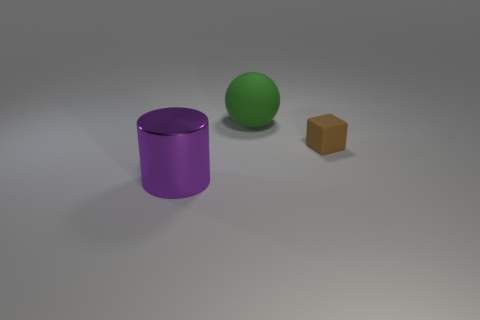Subtract all cubes. How many objects are left? 2 Add 1 large gray cylinders. How many large gray cylinders exist? 1 Add 2 big purple cylinders. How many objects exist? 5 Subtract 0 red blocks. How many objects are left? 3 Subtract all red cylinders. How many brown spheres are left? 0 Subtract all large green objects. Subtract all purple cylinders. How many objects are left? 1 Add 3 large purple cylinders. How many large purple cylinders are left? 4 